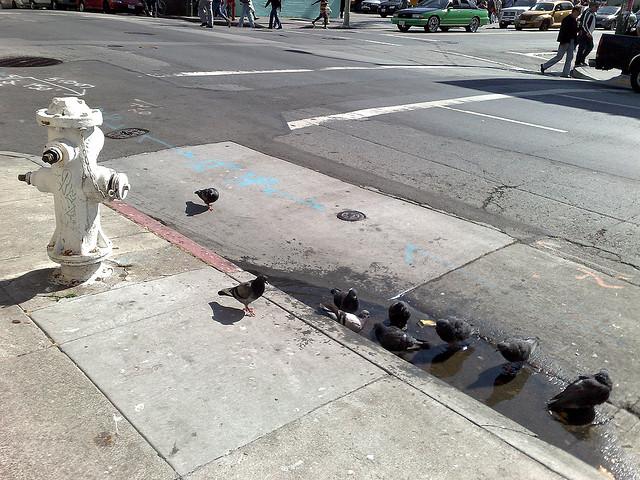What color is the fire hydrant?
Be succinct. White. How many birds?
Answer briefly. 9. Are there any cars on the street?
Give a very brief answer. Yes. 